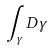<formula> <loc_0><loc_0><loc_500><loc_500>\int _ { \gamma } D \gamma</formula> 